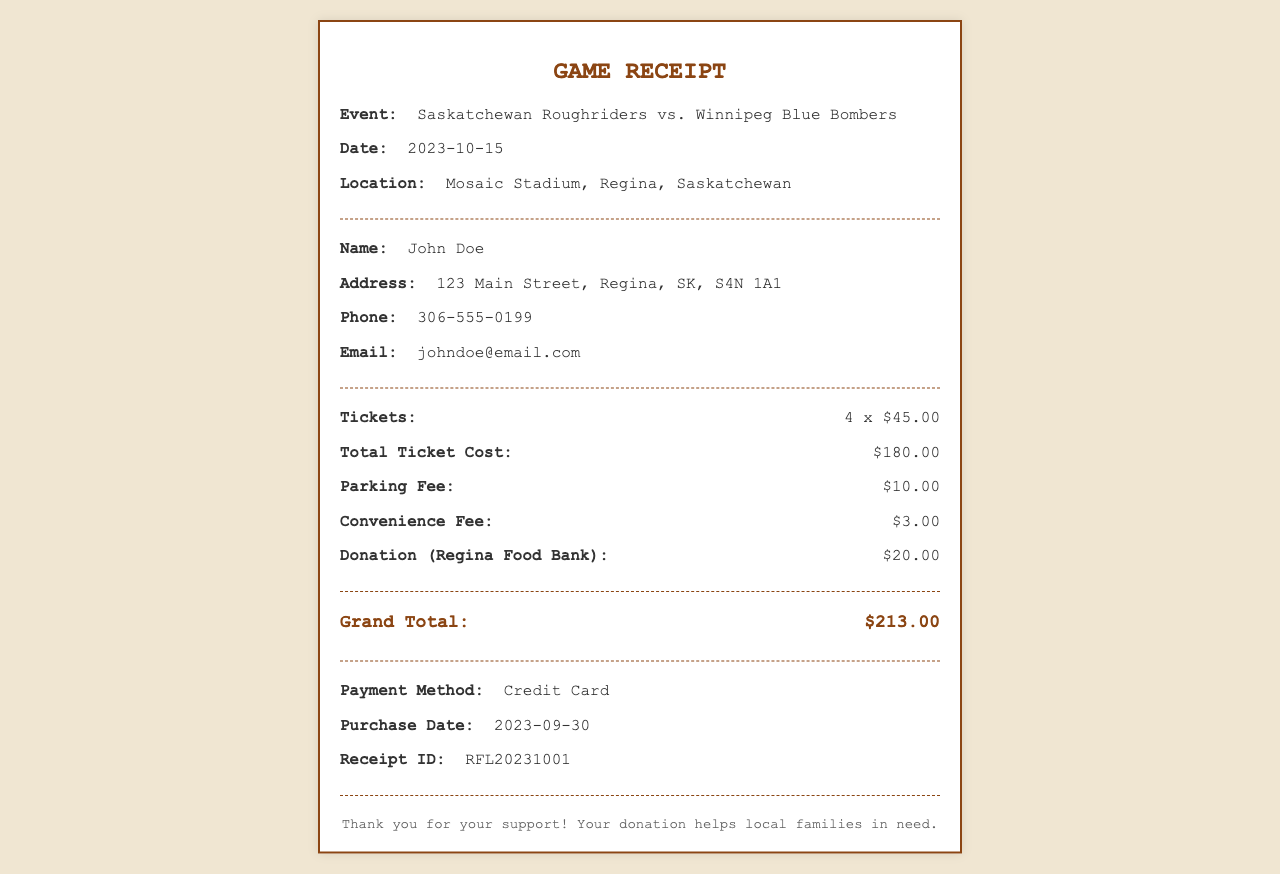What is the event name? The event name is mentioned at the top of the receipt.
Answer: Saskatchewan Roughriders vs. Winnipeg Blue Bombers What is the date of the event? The date is clearly stated in the document under the event details.
Answer: 2023-10-15 How many tickets were purchased? The number of tickets is specified in the ticket section of the receipt.
Answer: 4 What is the total ticket cost? The total ticket cost is calculated based on the price per ticket and the number of tickets.
Answer: $180.00 What is the parking fee? The parking fee is clearly listed in the fee section of the receipt.
Answer: $10.00 What was the total amount donated to the Regina Food Bank? The donation to the Regina Food Bank is specifically mentioned in the document.
Answer: $20.00 What is the grand total? The grand total reflects the sum of all costs, including tickets and fees, at the bottom of the receipt.
Answer: $213.00 What payment method was used for the purchase? The payment method used is clearly stated in the payment section of the document.
Answer: Credit Card What is the receipt ID? The receipt ID is a unique identifier and is mentioned in the footer of the document.
Answer: RFL20231001 